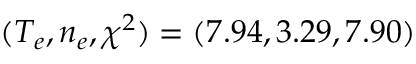<formula> <loc_0><loc_0><loc_500><loc_500>( T _ { e } , n _ { e } , \chi ^ { 2 } ) = ( 7 . 9 4 , 3 . 2 9 , 7 . 9 0 )</formula> 